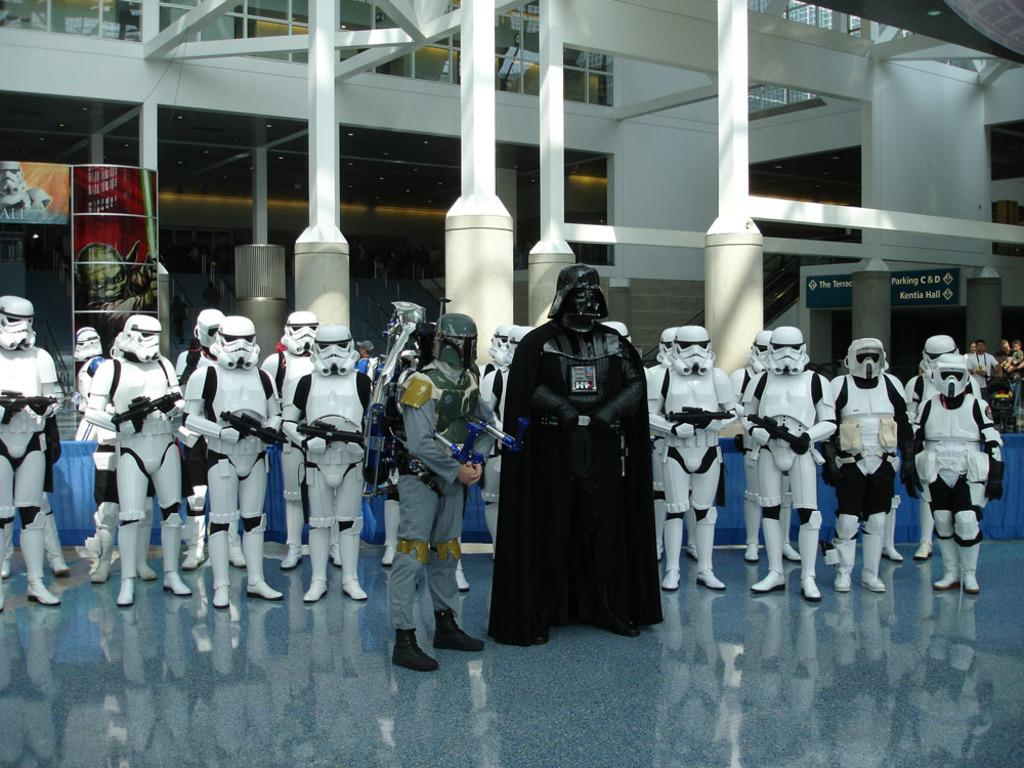What are the people in the image doing? The persons standing on the floor in the image are likely standing or waiting. What can be seen in the background of the image? In the background of the image, there are hoardings, a board, pillars, glasses, a ceiling, lights, and a wall. Can you describe the setting of the image? The image appears to be set in an indoor space with a ceiling, walls, and various background elements. What type of coast can be seen in the image? There is no coast visible in the image; it is set in an indoor space. How many people are sleeping in the image? There are no people sleeping in the image; the persons standing on the floor are not depicted as sleeping. 